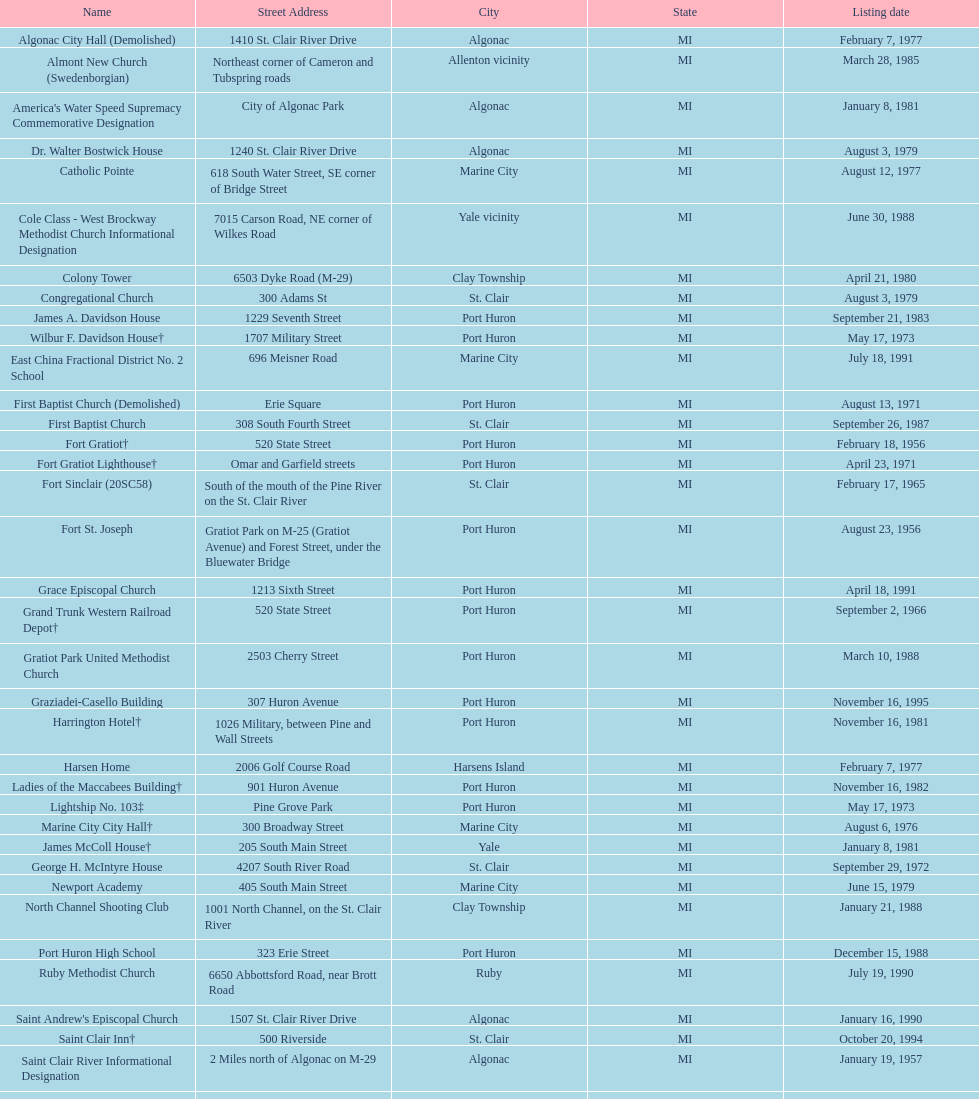Write the full table. {'header': ['Name', 'Street Address', 'City', 'State', 'Listing date'], 'rows': [['Algonac City Hall (Demolished)', '1410 St. Clair River Drive', 'Algonac', 'MI', 'February 7, 1977'], ['Almont New Church (Swedenborgian)', 'Northeast corner of Cameron and Tubspring roads', 'Allenton vicinity', 'MI', 'March 28, 1985'], ["America's Water Speed Supremacy Commemorative Designation", 'City of Algonac Park', 'Algonac', 'MI', 'January 8, 1981'], ['Dr. Walter Bostwick House', '1240 St. Clair River Drive', 'Algonac', 'MI', 'August 3, 1979'], ['Catholic Pointe', '618 South Water Street, SE corner of Bridge Street', 'Marine City', 'MI', 'August 12, 1977'], ['Cole Class - West Brockway Methodist Church Informational Designation', '7015 Carson Road, NE corner of Wilkes Road', 'Yale vicinity', 'MI', 'June 30, 1988'], ['Colony Tower', '6503 Dyke Road (M-29)', 'Clay Township', 'MI', 'April 21, 1980'], ['Congregational Church', '300 Adams St', 'St. Clair', 'MI', 'August 3, 1979'], ['James A. Davidson House', '1229 Seventh Street', 'Port Huron', 'MI', 'September 21, 1983'], ['Wilbur F. Davidson House†', '1707 Military Street', 'Port Huron', 'MI', 'May 17, 1973'], ['East China Fractional District No. 2 School', '696 Meisner Road', 'Marine City', 'MI', 'July 18, 1991'], ['First Baptist Church (Demolished)', 'Erie Square', 'Port Huron', 'MI', 'August 13, 1971'], ['First Baptist Church', '308 South Fourth Street', 'St. Clair', 'MI', 'September 26, 1987'], ['Fort Gratiot†', '520 State Street', 'Port Huron', 'MI', 'February 18, 1956'], ['Fort Gratiot Lighthouse†', 'Omar and Garfield streets', 'Port Huron', 'MI', 'April 23, 1971'], ['Fort Sinclair (20SC58)', 'South of the mouth of the Pine River on the St. Clair River', 'St. Clair', 'MI', 'February 17, 1965'], ['Fort St. Joseph', 'Gratiot Park on M-25 (Gratiot Avenue) and Forest Street, under the Bluewater Bridge', 'Port Huron', 'MI', 'August 23, 1956'], ['Grace Episcopal Church', '1213 Sixth Street', 'Port Huron', 'MI', 'April 18, 1991'], ['Grand Trunk Western Railroad Depot†', '520 State Street', 'Port Huron', 'MI', 'September 2, 1966'], ['Gratiot Park United Methodist Church', '2503 Cherry Street', 'Port Huron', 'MI', 'March 10, 1988'], ['Graziadei-Casello Building', '307 Huron Avenue', 'Port Huron', 'MI', 'November 16, 1995'], ['Harrington Hotel†', '1026 Military, between Pine and Wall Streets', 'Port Huron', 'MI', 'November 16, 1981'], ['Harsen Home', '2006 Golf Course Road', 'Harsens Island', 'MI', 'February 7, 1977'], ['Ladies of the Maccabees Building†', '901 Huron Avenue', 'Port Huron', 'MI', 'November 16, 1982'], ['Lightship No. 103‡', 'Pine Grove Park', 'Port Huron', 'MI', 'May 17, 1973'], ['Marine City City Hall†', '300 Broadway Street', 'Marine City', 'MI', 'August 6, 1976'], ['James McColl House†', '205 South Main Street', 'Yale', 'MI', 'January 8, 1981'], ['George H. McIntyre House', '4207 South River Road', 'St. Clair', 'MI', 'September 29, 1972'], ['Newport Academy', '405 South Main Street', 'Marine City', 'MI', 'June 15, 1979'], ['North Channel Shooting Club', '1001 North Channel, on the St. Clair River', 'Clay Township', 'MI', 'January 21, 1988'], ['Port Huron High School', '323 Erie Street', 'Port Huron', 'MI', 'December 15, 1988'], ['Ruby Methodist Church', '6650 Abbottsford Road, near Brott Road', 'Ruby', 'MI', 'July 19, 1990'], ["Saint Andrew's Episcopal Church", '1507 St. Clair River Drive', 'Algonac', 'MI', 'January 16, 1990'], ['Saint Clair Inn†', '500 Riverside', 'St. Clair', 'MI', 'October 20, 1994'], ['Saint Clair River Informational Designation', '2 Miles north of Algonac on M-29', 'Algonac', 'MI', 'January 19, 1957'], ['St. Clair River Tunnel‡', 'Between Johnstone & Beard, near 10th Street (portal site)', 'Port Huron', 'MI', 'August 23, 1956'], ['Saint Johannes Evangelische Kirche', '710 Pine Street, at Seventh Street', 'Port Huron', 'MI', 'March 19, 1980'], ["Saint Mary's Catholic Church and Rectory", '415 North Sixth Street, between Vine and Orchard streets', 'St. Clair', 'MI', 'September 25, 1985'], ['Jefferson Sheldon House', '807 Prospect Place', 'Port Huron', 'MI', 'April 19, 1990'], ['Trinity Evangelical Lutheran Church', '1517 Tenth Street', 'Port Huron', 'MI', 'August 29, 1996'], ['Wales Township Hall', '1372 Wales Center', 'Wales Township', 'MI', 'July 18, 1996'], ['Ward-Holland House†', '433 North Main Street', 'Marine City', 'MI', 'May 5, 1964'], ['E. C. Williams House', '2511 Tenth Avenue, between Hancock and Church streets', 'Port Huron', 'MI', 'November 18, 1993'], ['C. H. Wills & Company', 'Chrysler Plant, 840 Huron Avenue', 'Marysville', 'MI', 'June 23, 1983'], ["Woman's Benefit Association Building", '1338 Military Street', 'Port Huron', 'MI', 'December 15, 1988']]} Which city is home to the greatest number of historic sites, existing or demolished? Port Huron. 